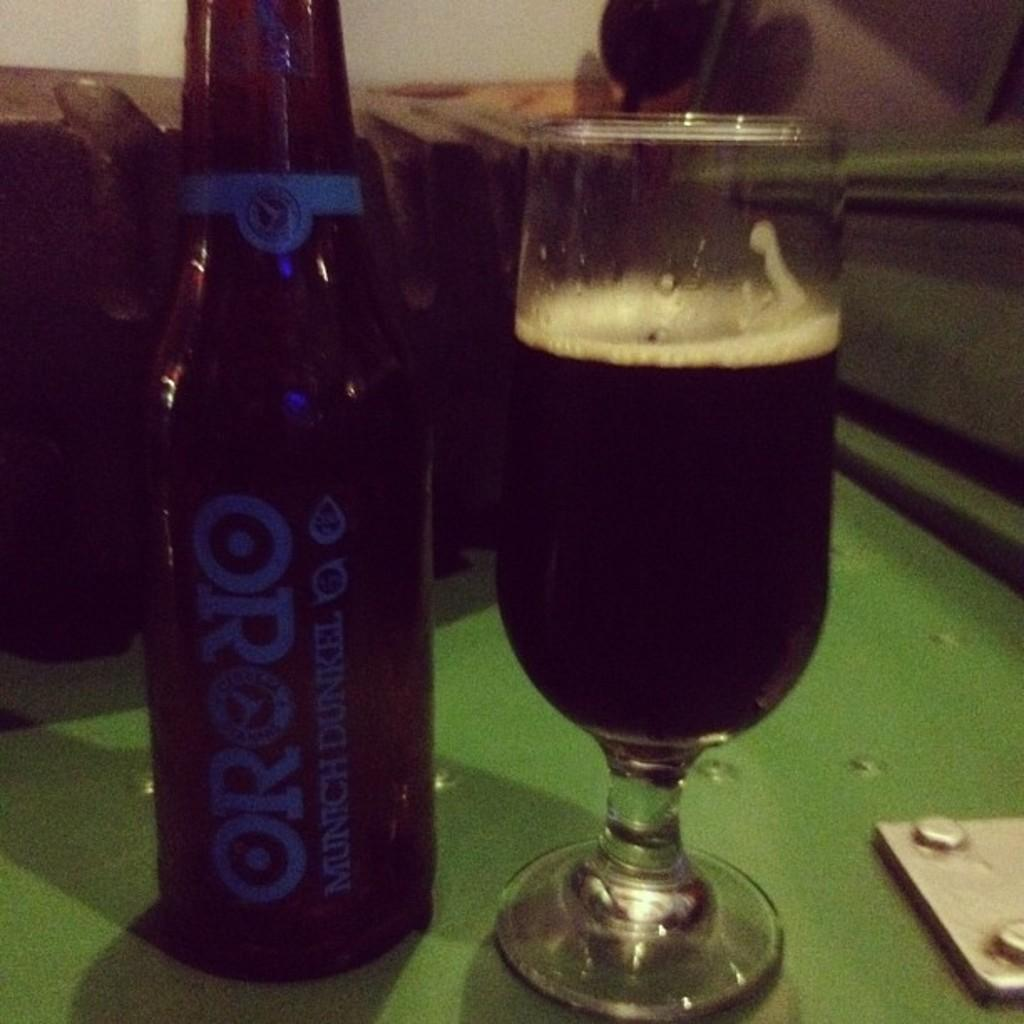What type of object can be seen in the image? There is a bottle and a glass in the image. What is the surface that the objects are placed on? The objects are on a green surface. How would you describe the background of the image? The background is blurred. Is there any text or writing on any of the objects? Yes, there is writing on the bottle. What type of wound can be seen on the rod in the image? There is no rod or wound present in the image. How many stores are visible in the image? There are no stores visible in the image. 